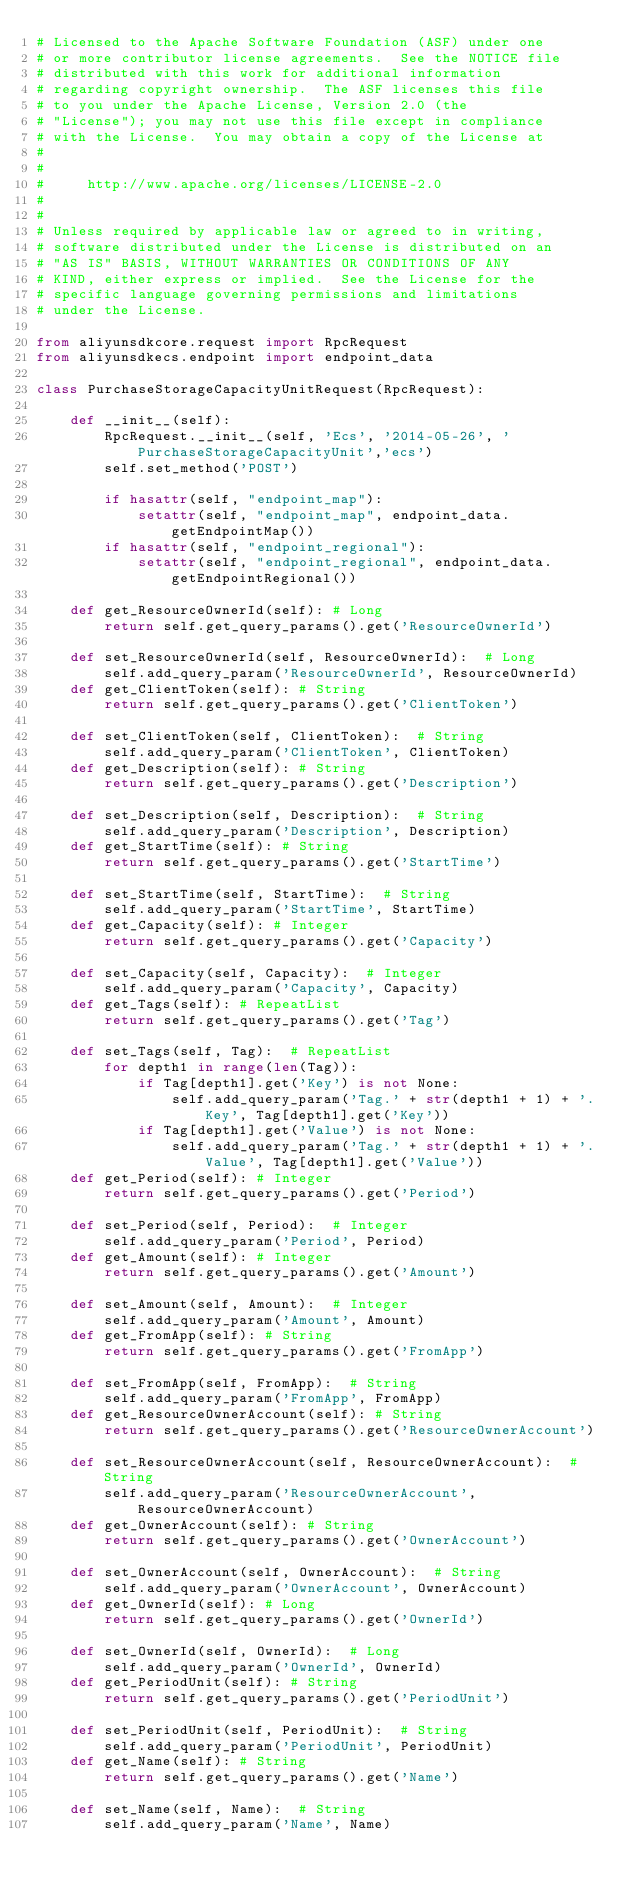<code> <loc_0><loc_0><loc_500><loc_500><_Python_># Licensed to the Apache Software Foundation (ASF) under one
# or more contributor license agreements.  See the NOTICE file
# distributed with this work for additional information
# regarding copyright ownership.  The ASF licenses this file
# to you under the Apache License, Version 2.0 (the
# "License"); you may not use this file except in compliance
# with the License.  You may obtain a copy of the License at
#
#
#     http://www.apache.org/licenses/LICENSE-2.0
#
#
# Unless required by applicable law or agreed to in writing,
# software distributed under the License is distributed on an
# "AS IS" BASIS, WITHOUT WARRANTIES OR CONDITIONS OF ANY
# KIND, either express or implied.  See the License for the
# specific language governing permissions and limitations
# under the License.

from aliyunsdkcore.request import RpcRequest
from aliyunsdkecs.endpoint import endpoint_data

class PurchaseStorageCapacityUnitRequest(RpcRequest):

	def __init__(self):
		RpcRequest.__init__(self, 'Ecs', '2014-05-26', 'PurchaseStorageCapacityUnit','ecs')
		self.set_method('POST')

		if hasattr(self, "endpoint_map"):
			setattr(self, "endpoint_map", endpoint_data.getEndpointMap())
		if hasattr(self, "endpoint_regional"):
			setattr(self, "endpoint_regional", endpoint_data.getEndpointRegional())

	def get_ResourceOwnerId(self): # Long
		return self.get_query_params().get('ResourceOwnerId')

	def set_ResourceOwnerId(self, ResourceOwnerId):  # Long
		self.add_query_param('ResourceOwnerId', ResourceOwnerId)
	def get_ClientToken(self): # String
		return self.get_query_params().get('ClientToken')

	def set_ClientToken(self, ClientToken):  # String
		self.add_query_param('ClientToken', ClientToken)
	def get_Description(self): # String
		return self.get_query_params().get('Description')

	def set_Description(self, Description):  # String
		self.add_query_param('Description', Description)
	def get_StartTime(self): # String
		return self.get_query_params().get('StartTime')

	def set_StartTime(self, StartTime):  # String
		self.add_query_param('StartTime', StartTime)
	def get_Capacity(self): # Integer
		return self.get_query_params().get('Capacity')

	def set_Capacity(self, Capacity):  # Integer
		self.add_query_param('Capacity', Capacity)
	def get_Tags(self): # RepeatList
		return self.get_query_params().get('Tag')

	def set_Tags(self, Tag):  # RepeatList
		for depth1 in range(len(Tag)):
			if Tag[depth1].get('Key') is not None:
				self.add_query_param('Tag.' + str(depth1 + 1) + '.Key', Tag[depth1].get('Key'))
			if Tag[depth1].get('Value') is not None:
				self.add_query_param('Tag.' + str(depth1 + 1) + '.Value', Tag[depth1].get('Value'))
	def get_Period(self): # Integer
		return self.get_query_params().get('Period')

	def set_Period(self, Period):  # Integer
		self.add_query_param('Period', Period)
	def get_Amount(self): # Integer
		return self.get_query_params().get('Amount')

	def set_Amount(self, Amount):  # Integer
		self.add_query_param('Amount', Amount)
	def get_FromApp(self): # String
		return self.get_query_params().get('FromApp')

	def set_FromApp(self, FromApp):  # String
		self.add_query_param('FromApp', FromApp)
	def get_ResourceOwnerAccount(self): # String
		return self.get_query_params().get('ResourceOwnerAccount')

	def set_ResourceOwnerAccount(self, ResourceOwnerAccount):  # String
		self.add_query_param('ResourceOwnerAccount', ResourceOwnerAccount)
	def get_OwnerAccount(self): # String
		return self.get_query_params().get('OwnerAccount')

	def set_OwnerAccount(self, OwnerAccount):  # String
		self.add_query_param('OwnerAccount', OwnerAccount)
	def get_OwnerId(self): # Long
		return self.get_query_params().get('OwnerId')

	def set_OwnerId(self, OwnerId):  # Long
		self.add_query_param('OwnerId', OwnerId)
	def get_PeriodUnit(self): # String
		return self.get_query_params().get('PeriodUnit')

	def set_PeriodUnit(self, PeriodUnit):  # String
		self.add_query_param('PeriodUnit', PeriodUnit)
	def get_Name(self): # String
		return self.get_query_params().get('Name')

	def set_Name(self, Name):  # String
		self.add_query_param('Name', Name)
</code> 